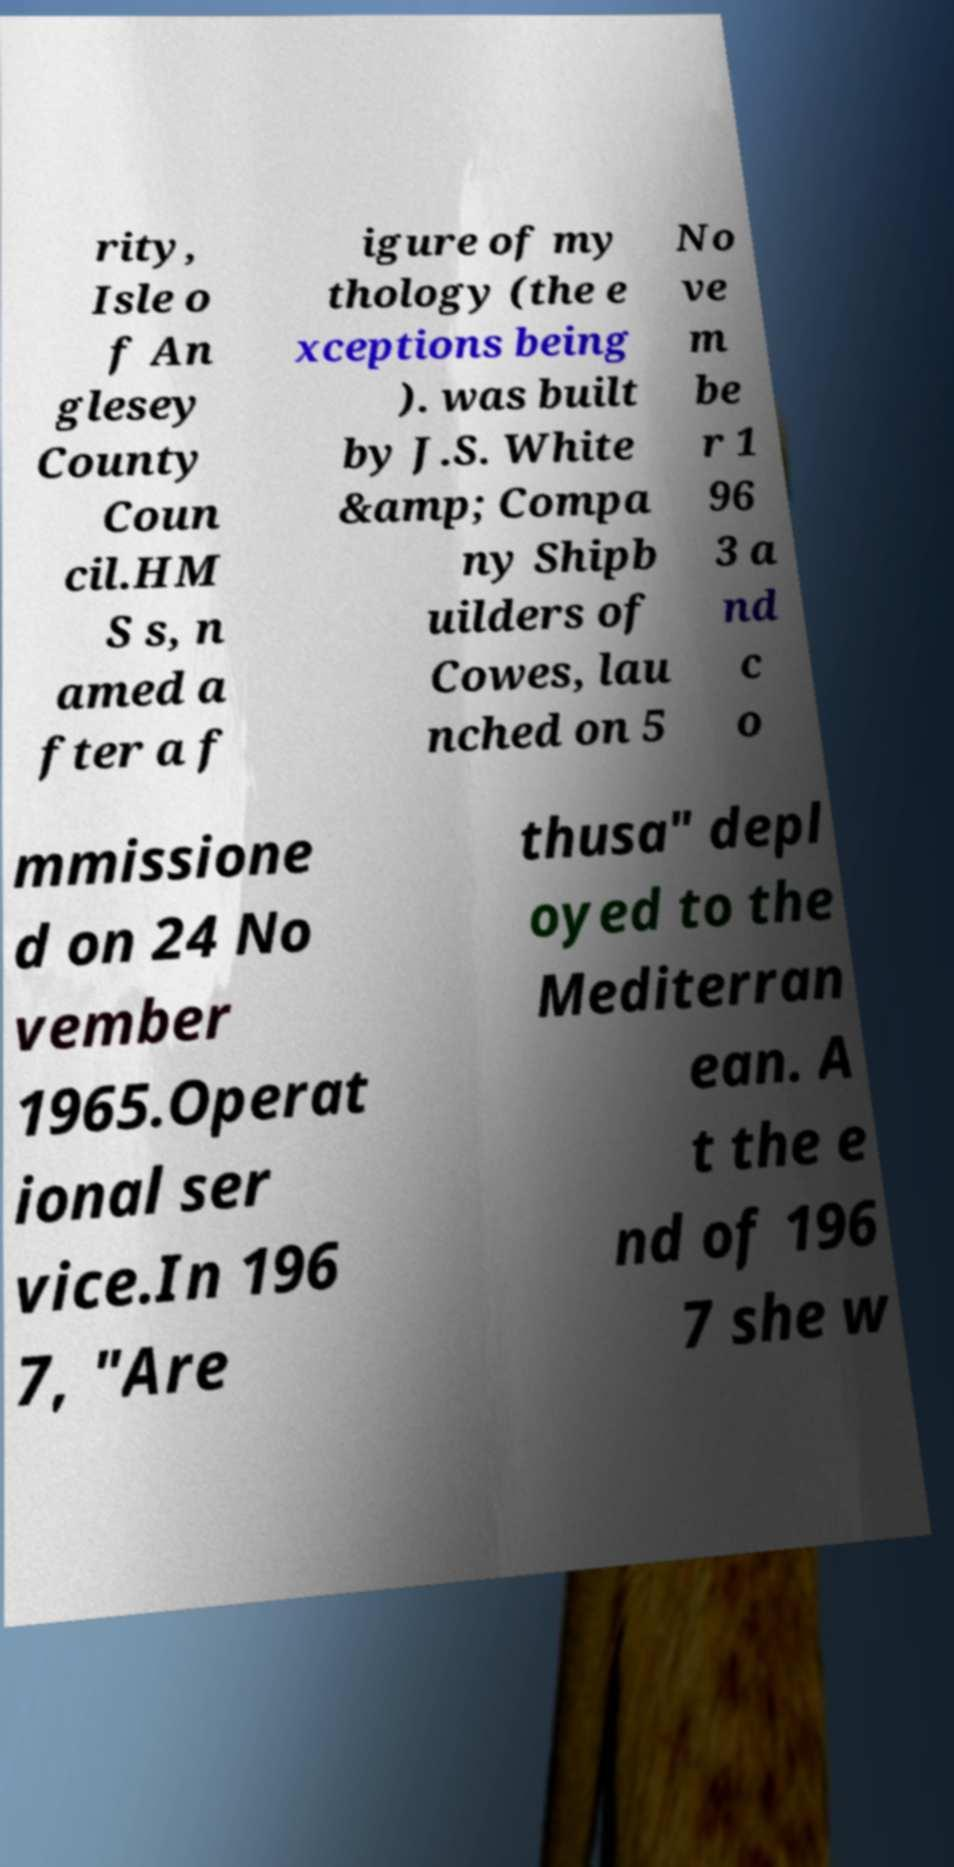I need the written content from this picture converted into text. Can you do that? rity, Isle o f An glesey County Coun cil.HM S s, n amed a fter a f igure of my thology (the e xceptions being ). was built by J.S. White &amp; Compa ny Shipb uilders of Cowes, lau nched on 5 No ve m be r 1 96 3 a nd c o mmissione d on 24 No vember 1965.Operat ional ser vice.In 196 7, "Are thusa" depl oyed to the Mediterran ean. A t the e nd of 196 7 she w 